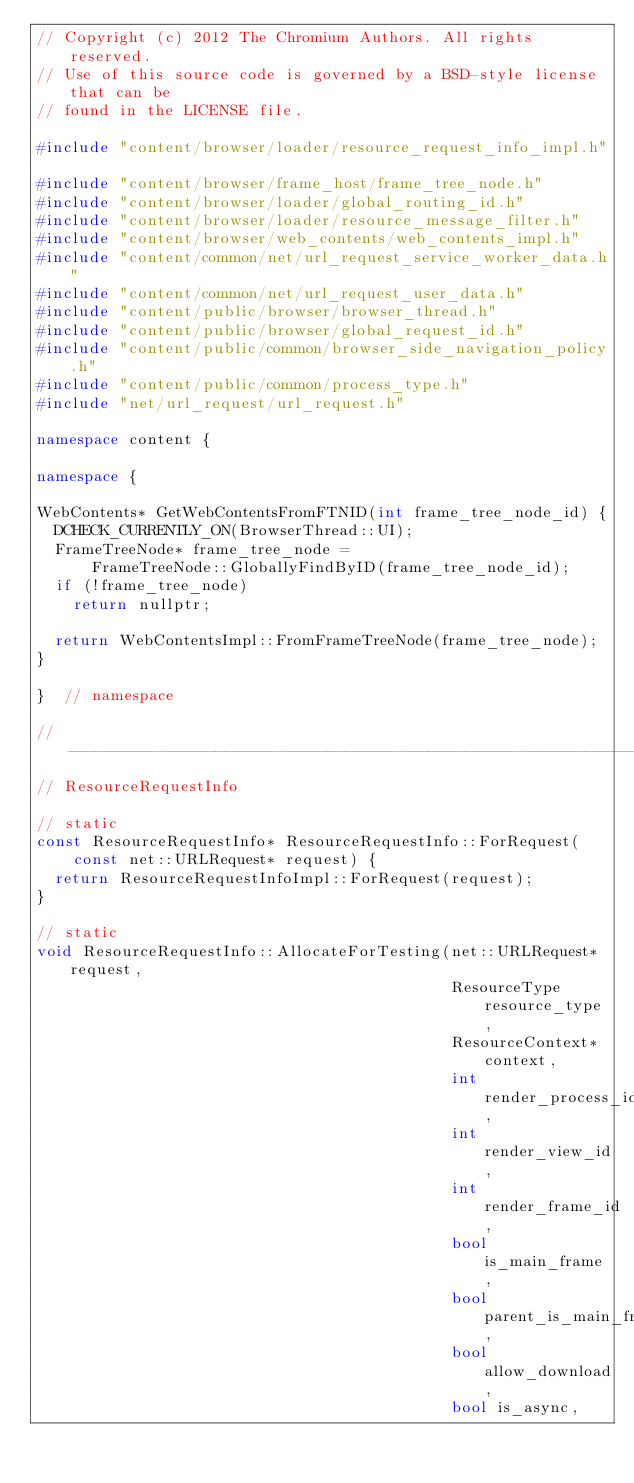Convert code to text. <code><loc_0><loc_0><loc_500><loc_500><_C++_>// Copyright (c) 2012 The Chromium Authors. All rights reserved.
// Use of this source code is governed by a BSD-style license that can be
// found in the LICENSE file.

#include "content/browser/loader/resource_request_info_impl.h"

#include "content/browser/frame_host/frame_tree_node.h"
#include "content/browser/loader/global_routing_id.h"
#include "content/browser/loader/resource_message_filter.h"
#include "content/browser/web_contents/web_contents_impl.h"
#include "content/common/net/url_request_service_worker_data.h"
#include "content/common/net/url_request_user_data.h"
#include "content/public/browser/browser_thread.h"
#include "content/public/browser/global_request_id.h"
#include "content/public/common/browser_side_navigation_policy.h"
#include "content/public/common/process_type.h"
#include "net/url_request/url_request.h"

namespace content {

namespace {

WebContents* GetWebContentsFromFTNID(int frame_tree_node_id) {
  DCHECK_CURRENTLY_ON(BrowserThread::UI);
  FrameTreeNode* frame_tree_node =
      FrameTreeNode::GloballyFindByID(frame_tree_node_id);
  if (!frame_tree_node)
    return nullptr;

  return WebContentsImpl::FromFrameTreeNode(frame_tree_node);
}

}  // namespace

// ----------------------------------------------------------------------------
// ResourceRequestInfo

// static
const ResourceRequestInfo* ResourceRequestInfo::ForRequest(
    const net::URLRequest* request) {
  return ResourceRequestInfoImpl::ForRequest(request);
}

// static
void ResourceRequestInfo::AllocateForTesting(net::URLRequest* request,
                                             ResourceType resource_type,
                                             ResourceContext* context,
                                             int render_process_id,
                                             int render_view_id,
                                             int render_frame_id,
                                             bool is_main_frame,
                                             bool parent_is_main_frame,
                                             bool allow_download,
                                             bool is_async,</code> 